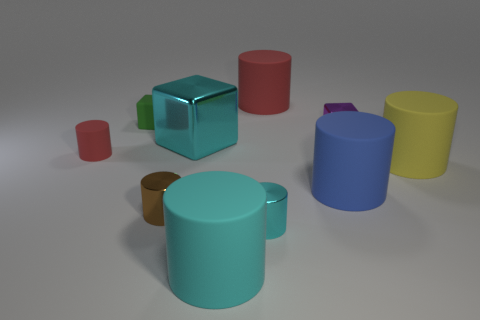Subtract all cyan cubes. How many cubes are left? 2 Subtract all metallic blocks. How many blocks are left? 1 Subtract all blocks. How many objects are left? 7 Subtract 2 cylinders. How many cylinders are left? 5 Subtract all purple cylinders. Subtract all cyan cubes. How many cylinders are left? 7 Subtract all blue cubes. How many gray cylinders are left? 0 Subtract all tiny green metallic cubes. Subtract all blue matte things. How many objects are left? 9 Add 7 cyan objects. How many cyan objects are left? 10 Add 1 green matte things. How many green matte things exist? 2 Subtract 0 gray blocks. How many objects are left? 10 